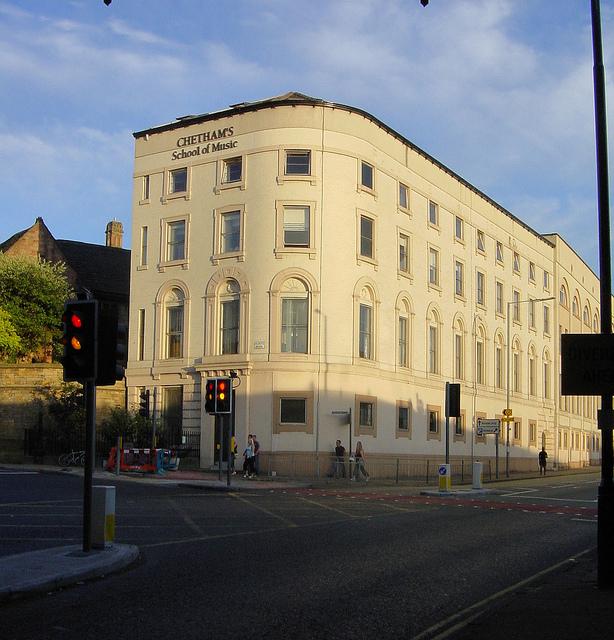Is this probably near a beach?
Concise answer only. No. How many red lights are showing?
Short answer required. 2. What type of building is this?
Quick response, please. School. What color is the traffic light glowing?
Keep it brief. Red. Is this a sports shop?
Keep it brief. No. What is the predominant color in this picture?
Give a very brief answer. White. What was the sexual orientation of the person that designed parking area of this building?
Give a very brief answer. Straight. Are there lights on?
Quick response, please. Yes. What color is the bench?
Short answer required. Red. What are the words on the building?
Answer briefly. Chetham's school of music. What is the name of the school?
Be succinct. Cramps. 